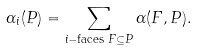Convert formula to latex. <formula><loc_0><loc_0><loc_500><loc_500>\alpha _ { i } ( P ) = \sum _ { i - \text {faces } F \subseteq P } \alpha ( F , P ) .</formula> 